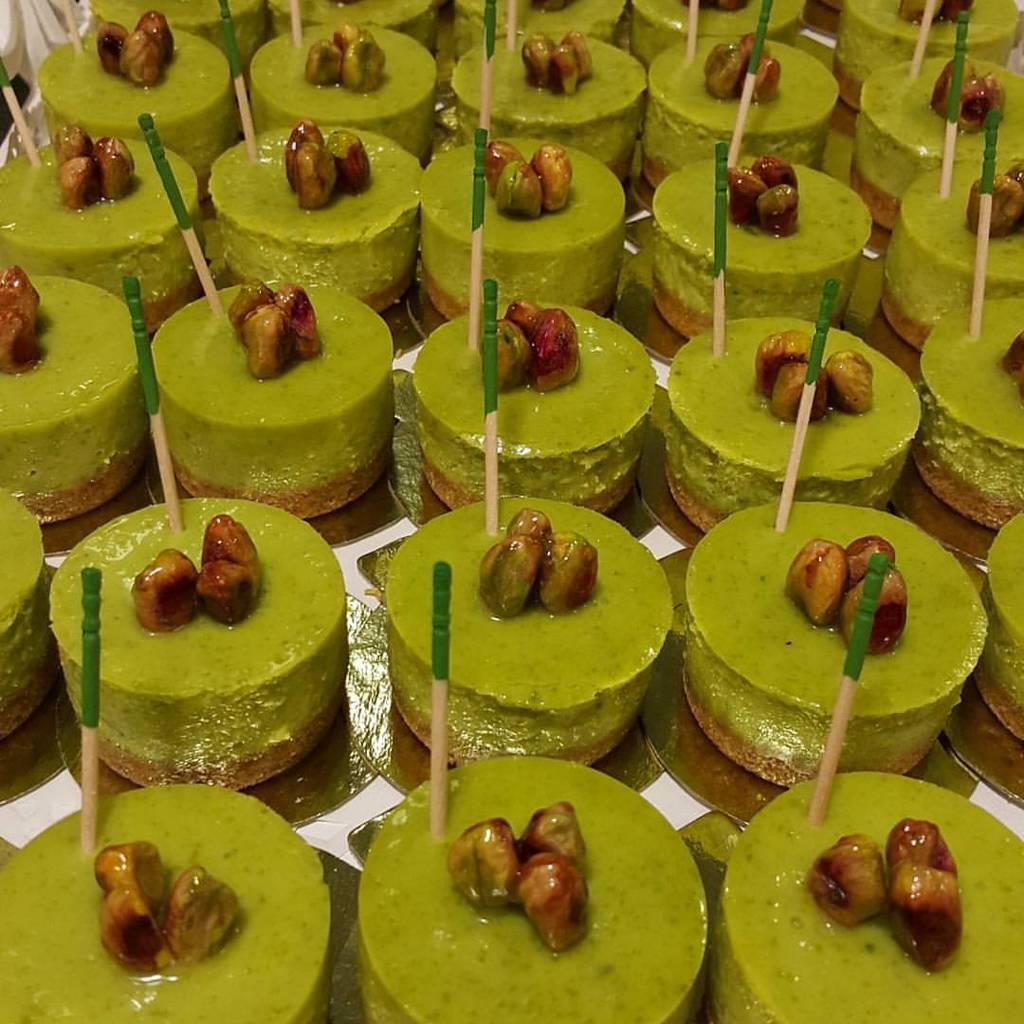What type of objects can be seen in the image? There are food items and wooden sticks in the image. Can you describe the food items in the image? Unfortunately, the specific food items cannot be identified from the provided facts. What might the wooden sticks be used for? The wooden sticks could be used for various purposes, such as skewering or stirring the food items. What type of flower is present in the image? There is no flower present in the image; it only contains food items and wooden sticks. How many people are in the group shown in the image? There is no group of people present in the image; it only contains food items and wooden sticks. 